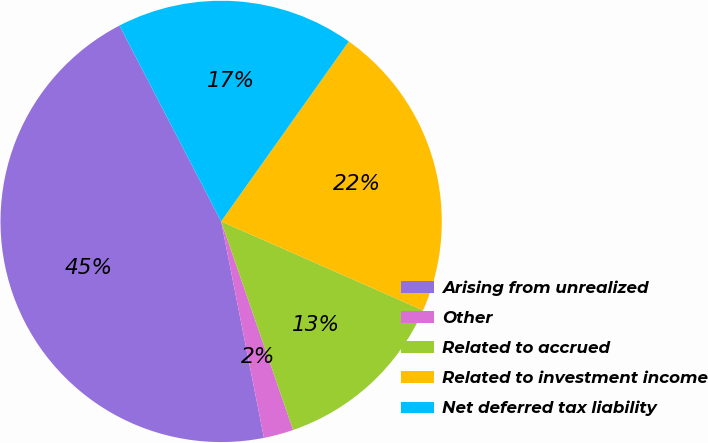Convert chart to OTSL. <chart><loc_0><loc_0><loc_500><loc_500><pie_chart><fcel>Arising from unrealized<fcel>Other<fcel>Related to accrued<fcel>Related to investment income<fcel>Net deferred tax liability<nl><fcel>45.49%<fcel>2.18%<fcel>13.11%<fcel>21.78%<fcel>17.44%<nl></chart> 